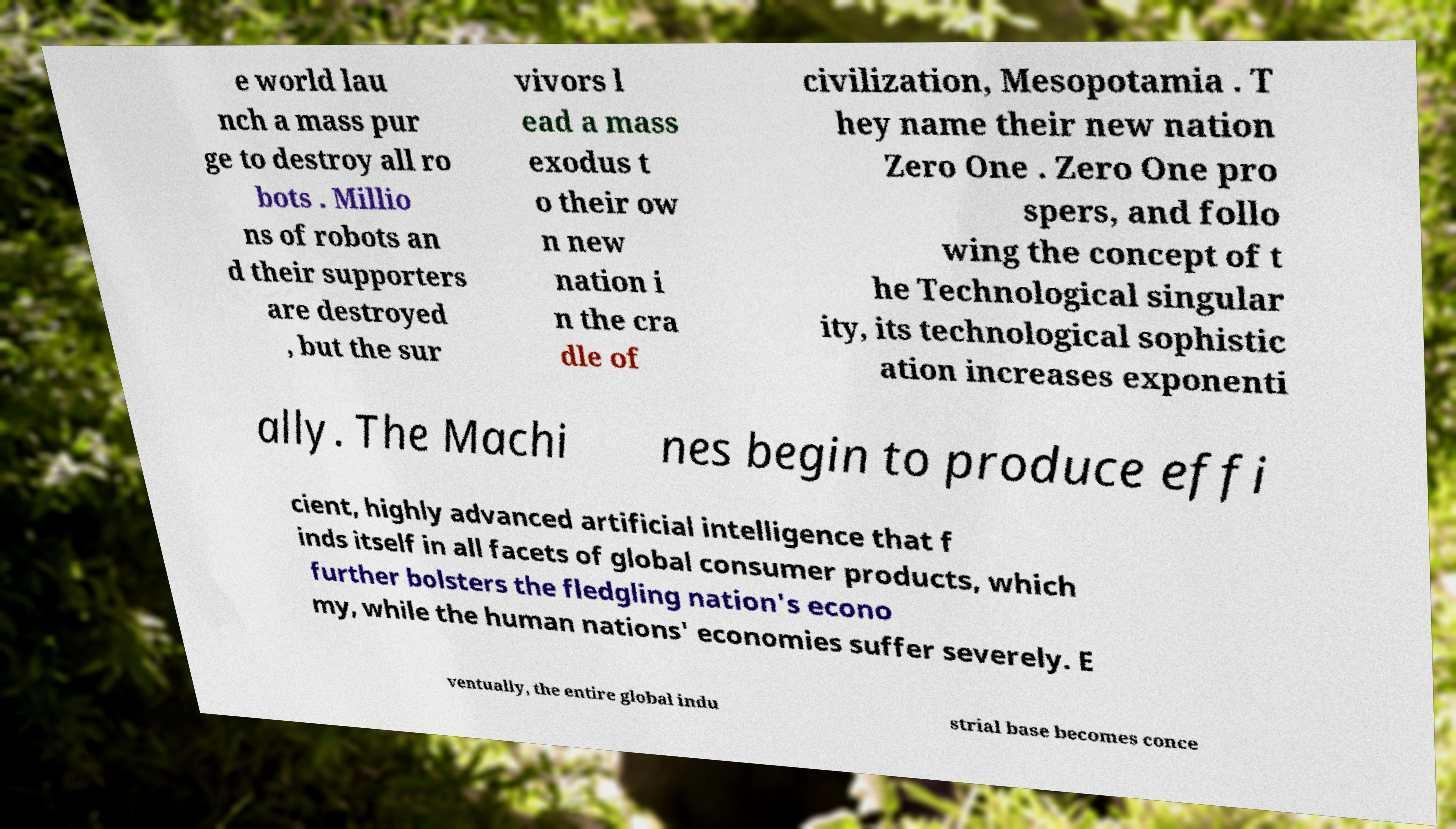Please identify and transcribe the text found in this image. e world lau nch a mass pur ge to destroy all ro bots . Millio ns of robots an d their supporters are destroyed , but the sur vivors l ead a mass exodus t o their ow n new nation i n the cra dle of civilization, Mesopotamia . T hey name their new nation Zero One . Zero One pro spers, and follo wing the concept of t he Technological singular ity, its technological sophistic ation increases exponenti ally. The Machi nes begin to produce effi cient, highly advanced artificial intelligence that f inds itself in all facets of global consumer products, which further bolsters the fledgling nation's econo my, while the human nations' economies suffer severely. E ventually, the entire global indu strial base becomes conce 